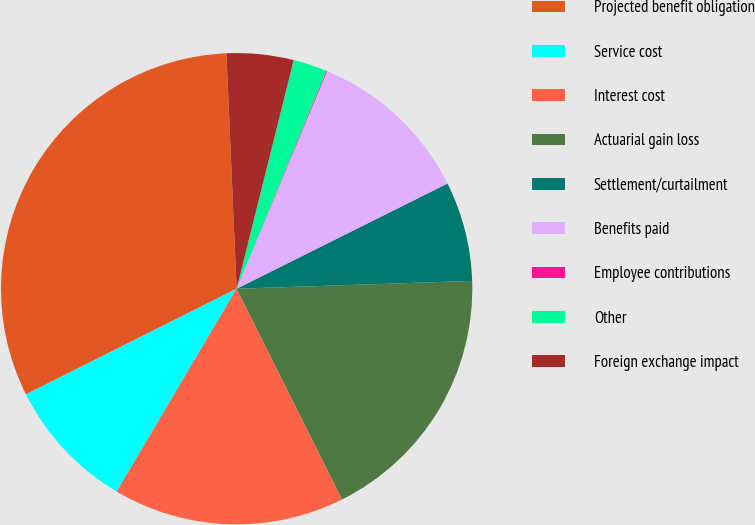Convert chart to OTSL. <chart><loc_0><loc_0><loc_500><loc_500><pie_chart><fcel>Projected benefit obligation<fcel>Service cost<fcel>Interest cost<fcel>Actuarial gain loss<fcel>Settlement/curtailment<fcel>Benefits paid<fcel>Employee contributions<fcel>Other<fcel>Foreign exchange impact<nl><fcel>31.7%<fcel>9.1%<fcel>15.88%<fcel>18.14%<fcel>6.84%<fcel>11.36%<fcel>0.06%<fcel>2.32%<fcel>4.58%<nl></chart> 